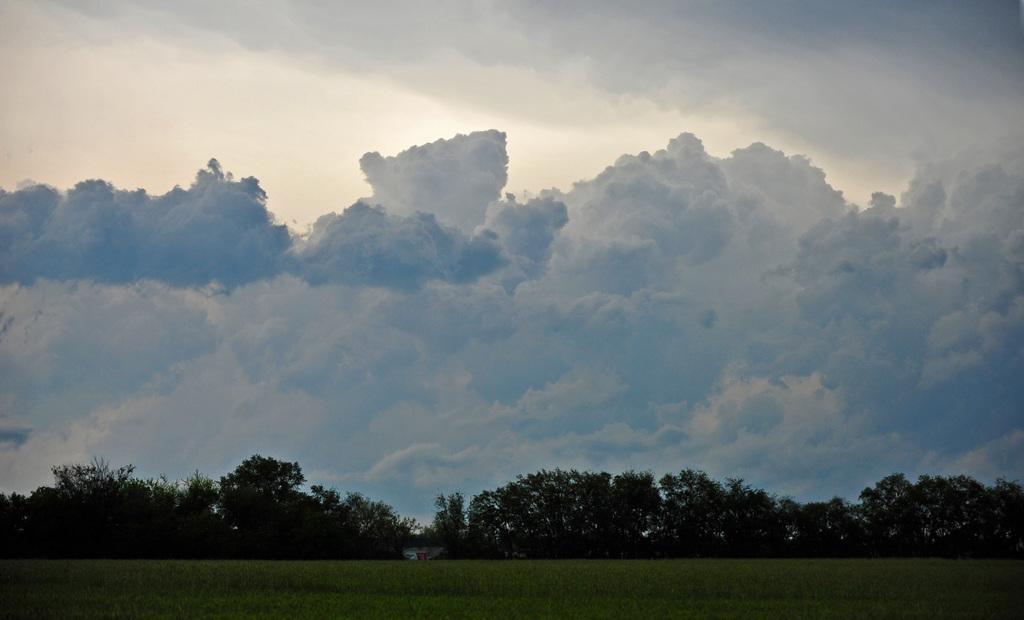How would you summarize this image in a sentence or two? In this picture I can observe some grass on the ground. There are some trees. In the background there is a sky with some clouds. 